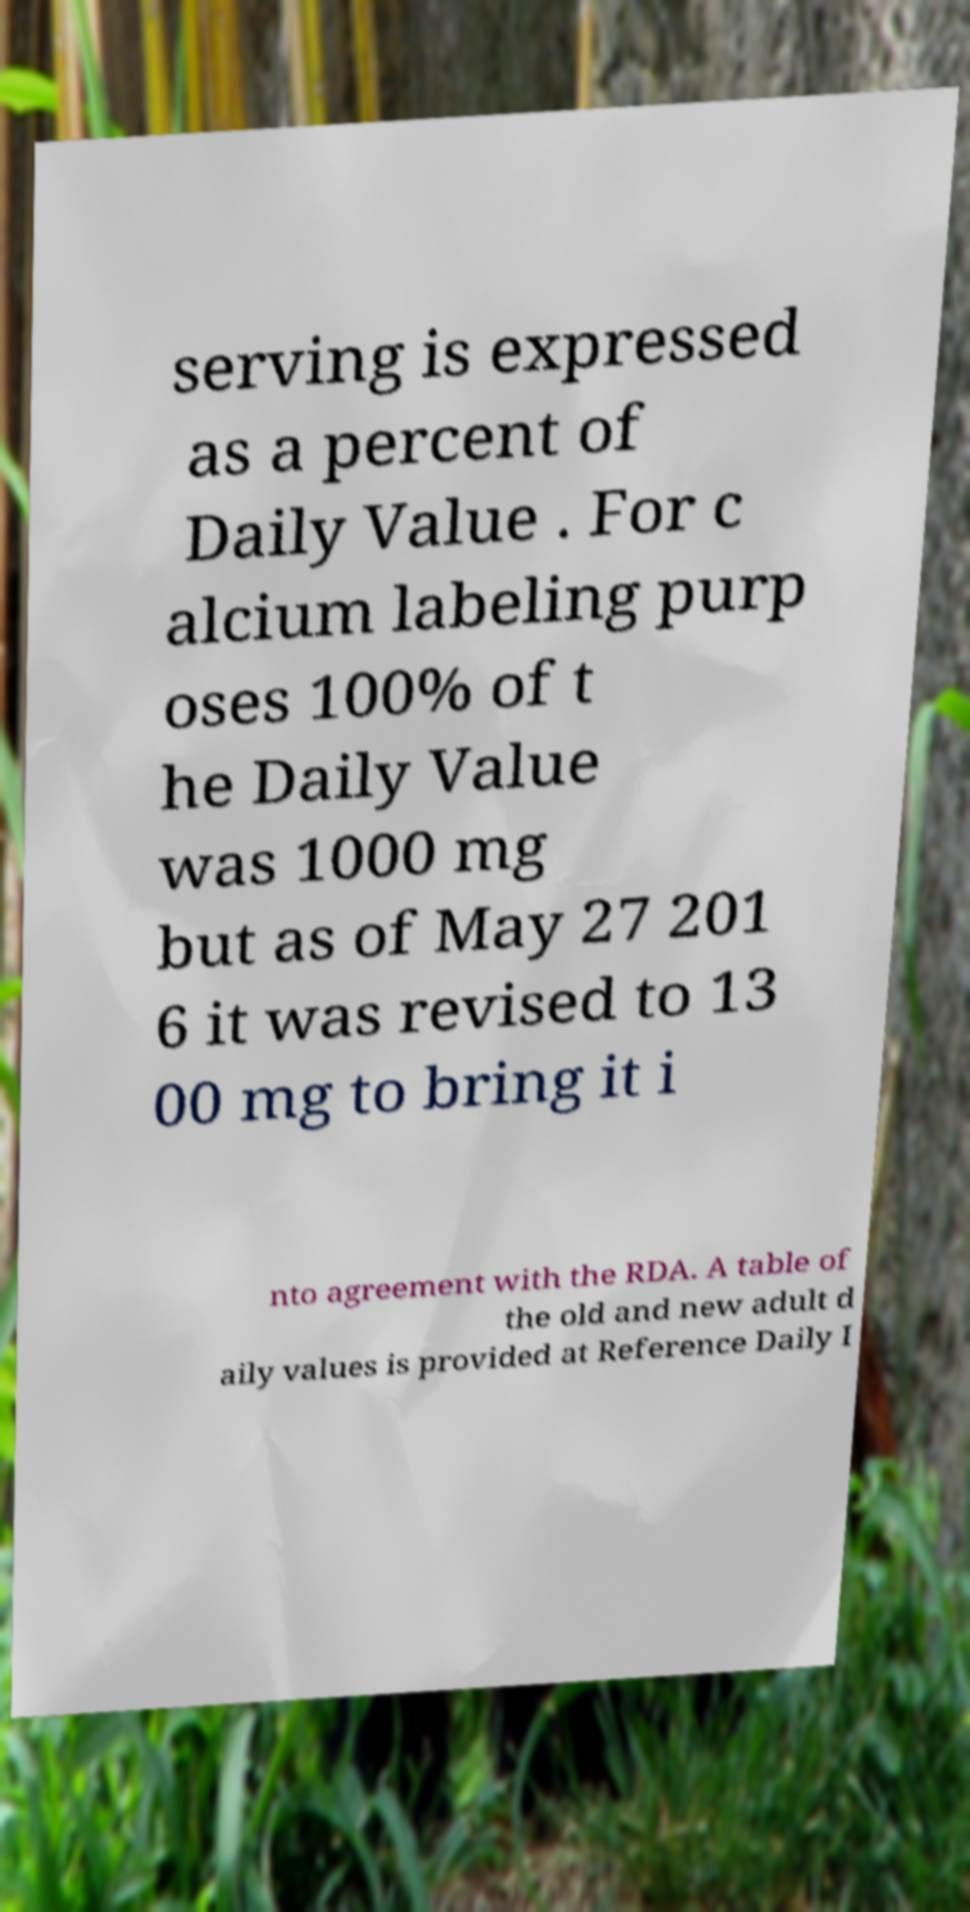For documentation purposes, I need the text within this image transcribed. Could you provide that? serving is expressed as a percent of Daily Value . For c alcium labeling purp oses 100% of t he Daily Value was 1000 mg but as of May 27 201 6 it was revised to 13 00 mg to bring it i nto agreement with the RDA. A table of the old and new adult d aily values is provided at Reference Daily I 